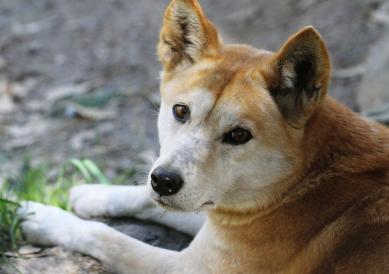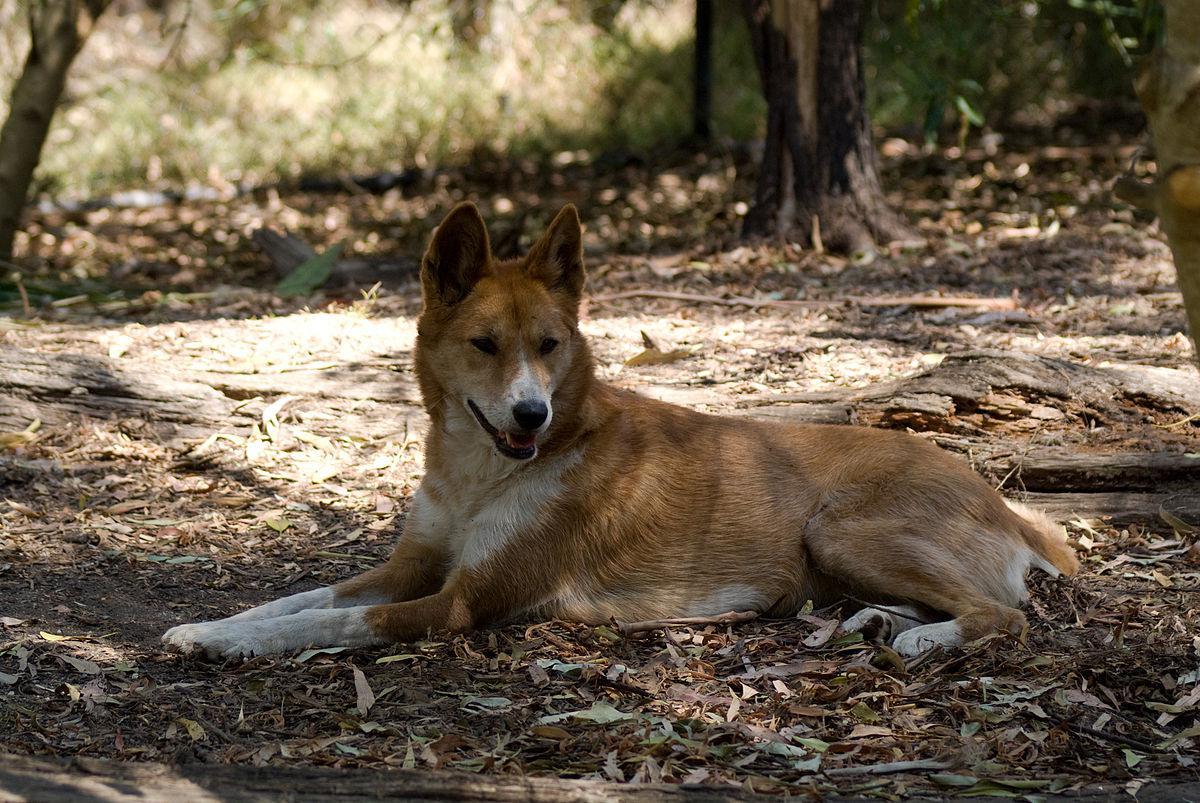The first image is the image on the left, the second image is the image on the right. Considering the images on both sides, is "The dog in the right image is on a grassy surface." valid? Answer yes or no. No. 